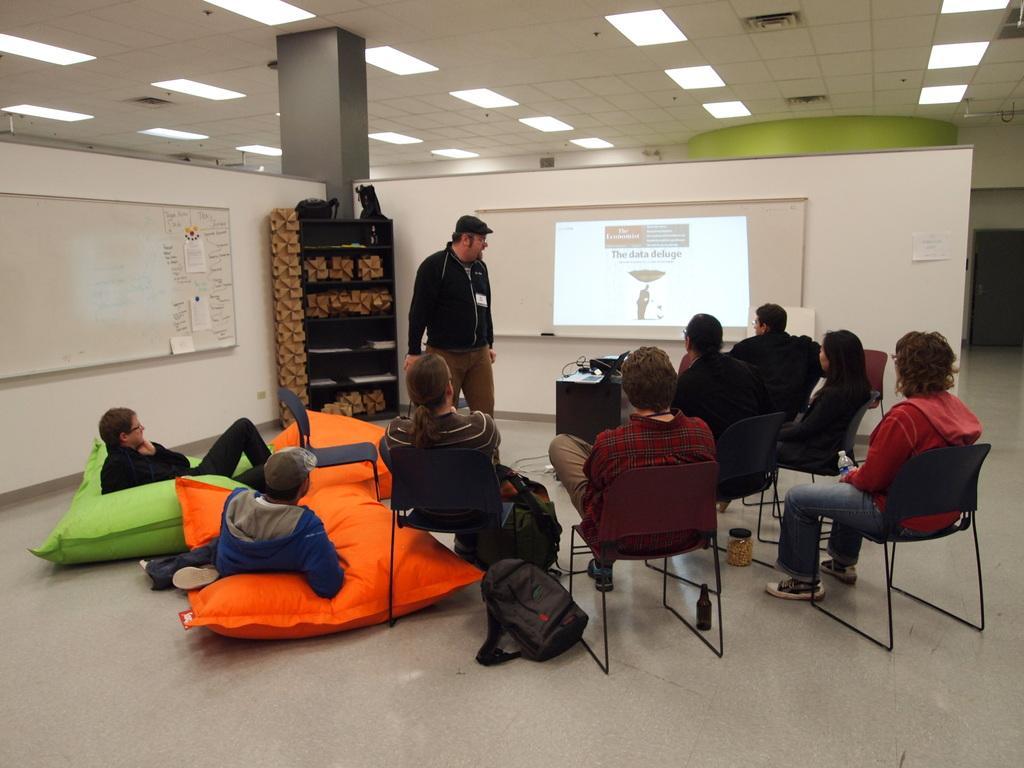How would you summarize this image in a sentence or two? In this image I can see some people sitting on chairs facing towards the back. I can see two more people lying on the floor by the bed. I can see a person standing in front of them. I can see a screen in the center of the image. I can see a wooden cupboard behind the person standing. I can see a board on the left hand side of the image. I can see a pillar and false ceiling at the top of the image.  